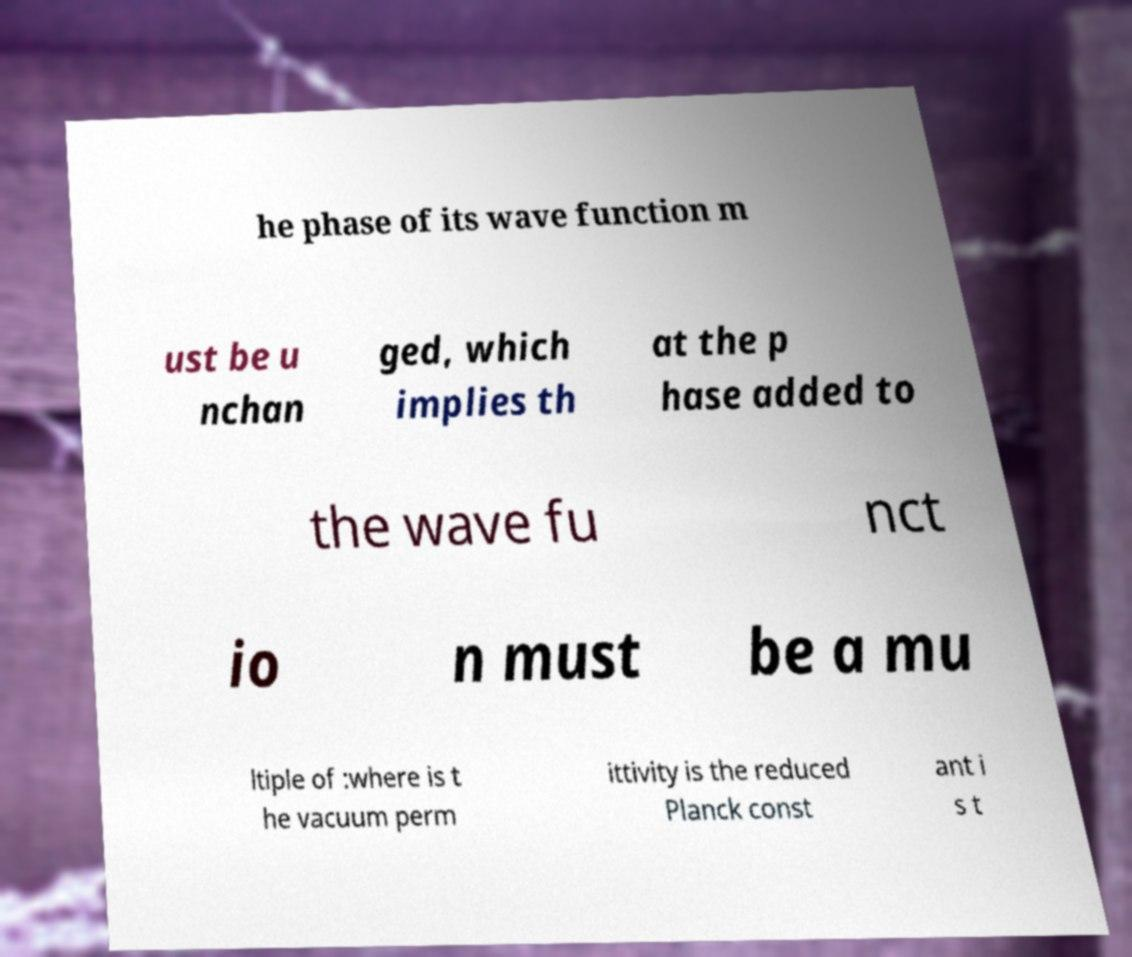Could you assist in decoding the text presented in this image and type it out clearly? he phase of its wave function m ust be u nchan ged, which implies th at the p hase added to the wave fu nct io n must be a mu ltiple of :where is t he vacuum perm ittivity is the reduced Planck const ant i s t 